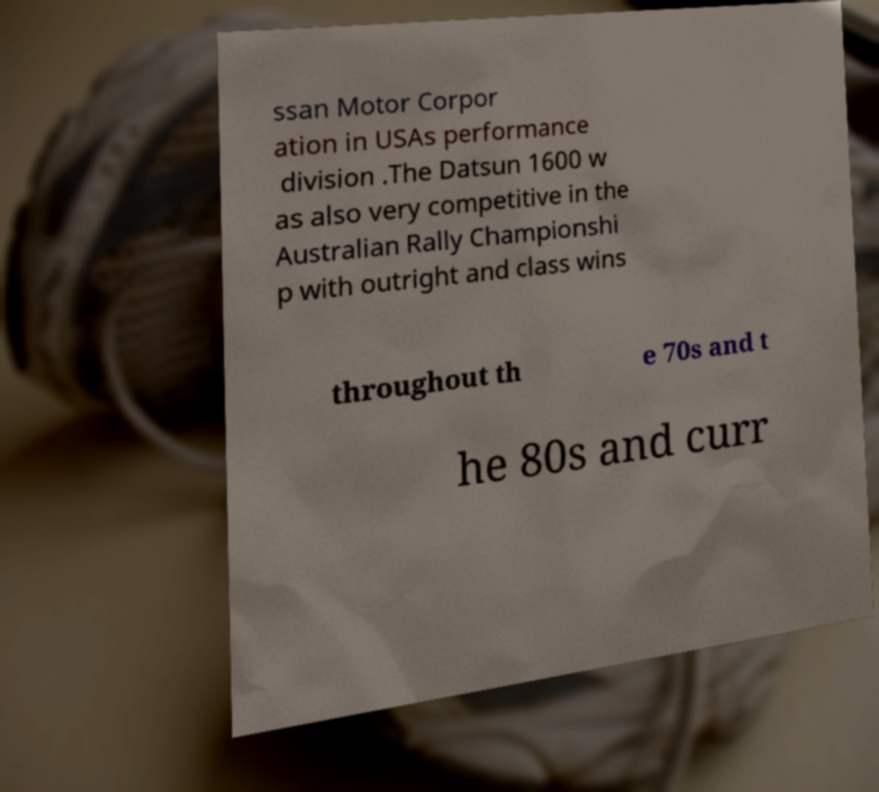Please identify and transcribe the text found in this image. ssan Motor Corpor ation in USAs performance division .The Datsun 1600 w as also very competitive in the Australian Rally Championshi p with outright and class wins throughout th e 70s and t he 80s and curr 